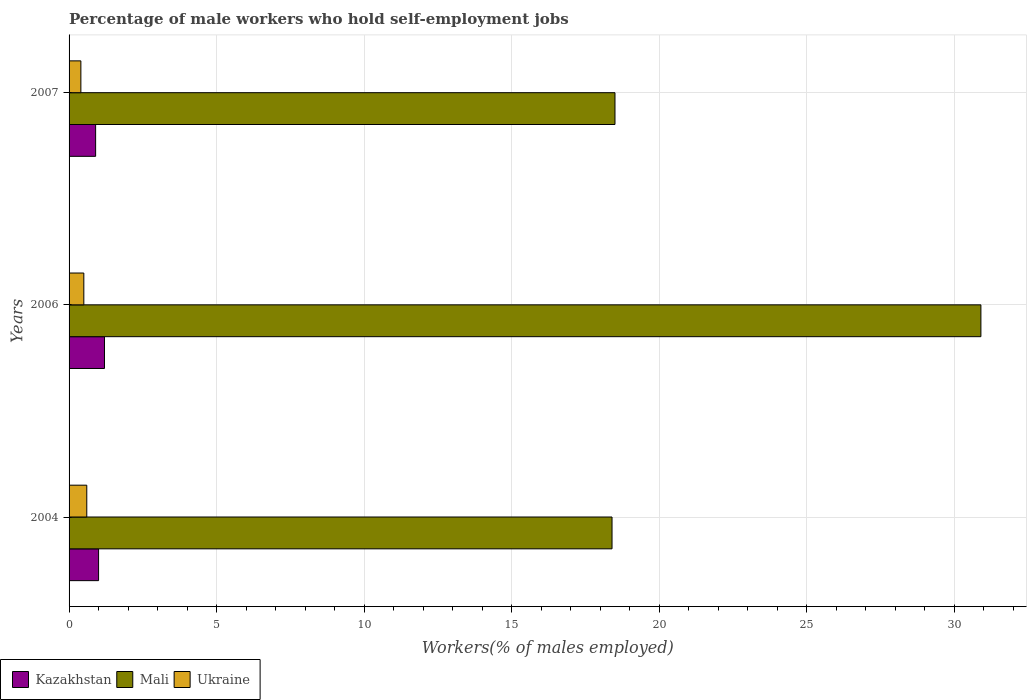How many groups of bars are there?
Your answer should be very brief. 3. Are the number of bars per tick equal to the number of legend labels?
Offer a terse response. Yes. Are the number of bars on each tick of the Y-axis equal?
Provide a succinct answer. Yes. How many bars are there on the 3rd tick from the bottom?
Keep it short and to the point. 3. What is the percentage of self-employed male workers in Mali in 2006?
Provide a short and direct response. 30.9. Across all years, what is the maximum percentage of self-employed male workers in Mali?
Your response must be concise. 30.9. Across all years, what is the minimum percentage of self-employed male workers in Ukraine?
Your response must be concise. 0.4. In which year was the percentage of self-employed male workers in Mali maximum?
Provide a succinct answer. 2006. What is the total percentage of self-employed male workers in Mali in the graph?
Your response must be concise. 67.8. What is the difference between the percentage of self-employed male workers in Ukraine in 2004 and that in 2006?
Your response must be concise. 0.1. What is the difference between the percentage of self-employed male workers in Mali in 2004 and the percentage of self-employed male workers in Ukraine in 2007?
Provide a short and direct response. 18. What is the average percentage of self-employed male workers in Mali per year?
Provide a short and direct response. 22.6. In the year 2006, what is the difference between the percentage of self-employed male workers in Ukraine and percentage of self-employed male workers in Mali?
Ensure brevity in your answer.  -30.4. In how many years, is the percentage of self-employed male workers in Mali greater than 11 %?
Your response must be concise. 3. What is the ratio of the percentage of self-employed male workers in Kazakhstan in 2004 to that in 2006?
Offer a terse response. 0.83. What is the difference between the highest and the second highest percentage of self-employed male workers in Ukraine?
Provide a succinct answer. 0.1. What is the difference between the highest and the lowest percentage of self-employed male workers in Kazakhstan?
Your answer should be compact. 0.3. Is the sum of the percentage of self-employed male workers in Kazakhstan in 2004 and 2007 greater than the maximum percentage of self-employed male workers in Mali across all years?
Give a very brief answer. No. What does the 3rd bar from the top in 2006 represents?
Your response must be concise. Kazakhstan. What does the 1st bar from the bottom in 2007 represents?
Provide a short and direct response. Kazakhstan. Is it the case that in every year, the sum of the percentage of self-employed male workers in Mali and percentage of self-employed male workers in Ukraine is greater than the percentage of self-employed male workers in Kazakhstan?
Keep it short and to the point. Yes. How many bars are there?
Offer a terse response. 9. What is the difference between two consecutive major ticks on the X-axis?
Provide a succinct answer. 5. Are the values on the major ticks of X-axis written in scientific E-notation?
Your answer should be compact. No. Where does the legend appear in the graph?
Give a very brief answer. Bottom left. How many legend labels are there?
Keep it short and to the point. 3. How are the legend labels stacked?
Your answer should be compact. Horizontal. What is the title of the graph?
Your answer should be very brief. Percentage of male workers who hold self-employment jobs. What is the label or title of the X-axis?
Provide a succinct answer. Workers(% of males employed). What is the Workers(% of males employed) of Mali in 2004?
Offer a terse response. 18.4. What is the Workers(% of males employed) in Ukraine in 2004?
Offer a terse response. 0.6. What is the Workers(% of males employed) of Kazakhstan in 2006?
Provide a short and direct response. 1.2. What is the Workers(% of males employed) of Mali in 2006?
Offer a terse response. 30.9. What is the Workers(% of males employed) of Ukraine in 2006?
Your response must be concise. 0.5. What is the Workers(% of males employed) in Kazakhstan in 2007?
Provide a short and direct response. 0.9. What is the Workers(% of males employed) of Mali in 2007?
Keep it short and to the point. 18.5. What is the Workers(% of males employed) in Ukraine in 2007?
Your answer should be compact. 0.4. Across all years, what is the maximum Workers(% of males employed) in Kazakhstan?
Keep it short and to the point. 1.2. Across all years, what is the maximum Workers(% of males employed) of Mali?
Provide a succinct answer. 30.9. Across all years, what is the maximum Workers(% of males employed) in Ukraine?
Provide a succinct answer. 0.6. Across all years, what is the minimum Workers(% of males employed) of Kazakhstan?
Ensure brevity in your answer.  0.9. Across all years, what is the minimum Workers(% of males employed) of Mali?
Offer a very short reply. 18.4. Across all years, what is the minimum Workers(% of males employed) of Ukraine?
Your answer should be very brief. 0.4. What is the total Workers(% of males employed) in Kazakhstan in the graph?
Give a very brief answer. 3.1. What is the total Workers(% of males employed) of Mali in the graph?
Your answer should be compact. 67.8. What is the total Workers(% of males employed) in Ukraine in the graph?
Your response must be concise. 1.5. What is the difference between the Workers(% of males employed) of Kazakhstan in 2004 and that in 2006?
Provide a short and direct response. -0.2. What is the difference between the Workers(% of males employed) in Kazakhstan in 2004 and that in 2007?
Offer a terse response. 0.1. What is the difference between the Workers(% of males employed) in Mali in 2004 and that in 2007?
Ensure brevity in your answer.  -0.1. What is the difference between the Workers(% of males employed) in Mali in 2006 and that in 2007?
Your answer should be very brief. 12.4. What is the difference between the Workers(% of males employed) of Ukraine in 2006 and that in 2007?
Give a very brief answer. 0.1. What is the difference between the Workers(% of males employed) in Kazakhstan in 2004 and the Workers(% of males employed) in Mali in 2006?
Provide a succinct answer. -29.9. What is the difference between the Workers(% of males employed) in Kazakhstan in 2004 and the Workers(% of males employed) in Ukraine in 2006?
Give a very brief answer. 0.5. What is the difference between the Workers(% of males employed) of Kazakhstan in 2004 and the Workers(% of males employed) of Mali in 2007?
Ensure brevity in your answer.  -17.5. What is the difference between the Workers(% of males employed) in Kazakhstan in 2004 and the Workers(% of males employed) in Ukraine in 2007?
Keep it short and to the point. 0.6. What is the difference between the Workers(% of males employed) in Kazakhstan in 2006 and the Workers(% of males employed) in Mali in 2007?
Provide a succinct answer. -17.3. What is the difference between the Workers(% of males employed) of Mali in 2006 and the Workers(% of males employed) of Ukraine in 2007?
Ensure brevity in your answer.  30.5. What is the average Workers(% of males employed) in Kazakhstan per year?
Your response must be concise. 1.03. What is the average Workers(% of males employed) in Mali per year?
Your response must be concise. 22.6. What is the average Workers(% of males employed) in Ukraine per year?
Provide a succinct answer. 0.5. In the year 2004, what is the difference between the Workers(% of males employed) in Kazakhstan and Workers(% of males employed) in Mali?
Give a very brief answer. -17.4. In the year 2004, what is the difference between the Workers(% of males employed) of Kazakhstan and Workers(% of males employed) of Ukraine?
Keep it short and to the point. 0.4. In the year 2006, what is the difference between the Workers(% of males employed) of Kazakhstan and Workers(% of males employed) of Mali?
Provide a short and direct response. -29.7. In the year 2006, what is the difference between the Workers(% of males employed) in Mali and Workers(% of males employed) in Ukraine?
Offer a very short reply. 30.4. In the year 2007, what is the difference between the Workers(% of males employed) in Kazakhstan and Workers(% of males employed) in Mali?
Give a very brief answer. -17.6. In the year 2007, what is the difference between the Workers(% of males employed) of Kazakhstan and Workers(% of males employed) of Ukraine?
Provide a short and direct response. 0.5. In the year 2007, what is the difference between the Workers(% of males employed) of Mali and Workers(% of males employed) of Ukraine?
Give a very brief answer. 18.1. What is the ratio of the Workers(% of males employed) of Kazakhstan in 2004 to that in 2006?
Make the answer very short. 0.83. What is the ratio of the Workers(% of males employed) of Mali in 2004 to that in 2006?
Your answer should be very brief. 0.6. What is the ratio of the Workers(% of males employed) of Mali in 2006 to that in 2007?
Ensure brevity in your answer.  1.67. What is the difference between the highest and the lowest Workers(% of males employed) in Ukraine?
Keep it short and to the point. 0.2. 